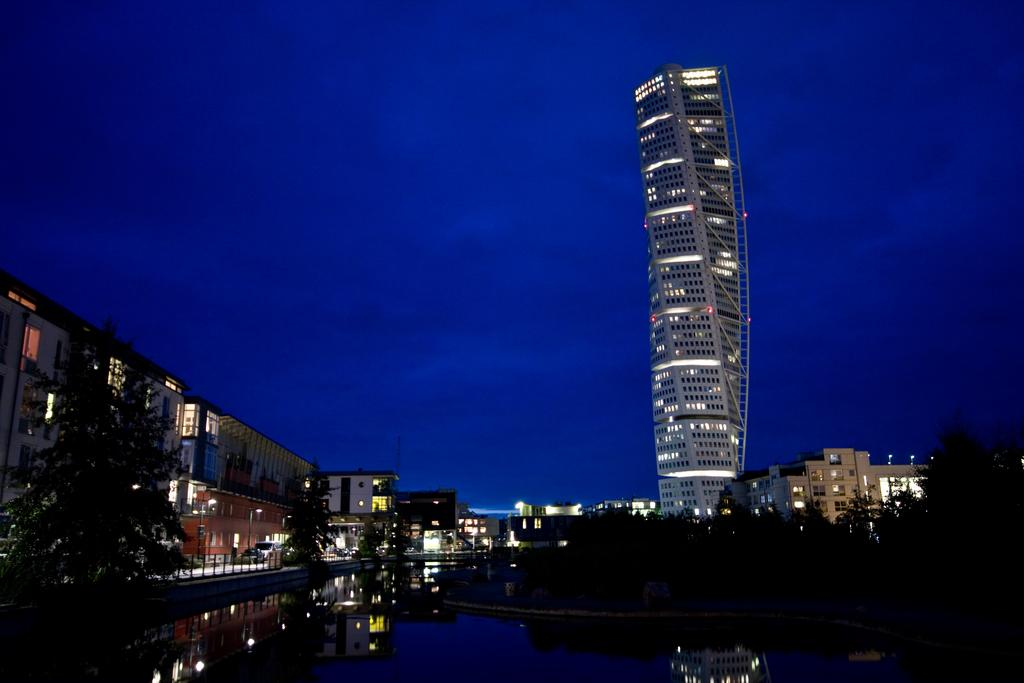What type of structures can be seen in the image? There are skyscrapers and buildings in the image. What are some other objects visible in the image? Street poles, street lights, barrier poles, and electric lights are present in the image. Can you describe the natural elements in the image? There is water visible in the image, as well as trees. What is visible in the background of the image? The sky is visible in the background of the image, with clouds present. Where is the mine located in the image? There is no mine present in the image. How does the house drop from the sky in the image? There is no house present in the image, and therefore it cannot drop from the sky. 